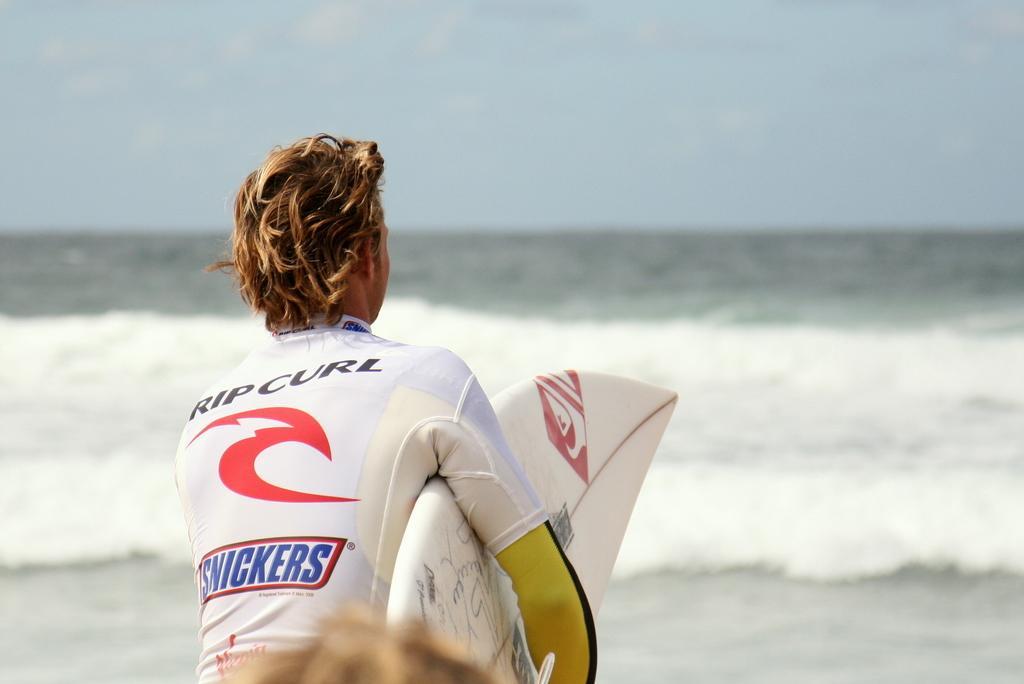How would you summarize this image in a sentence or two? At the bottom we can see hair of a person. In the foreground we can see a person holding a surfboard. In the center of the picture there is a water body. At the top it is sky. 